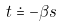<formula> <loc_0><loc_0><loc_500><loc_500>t \doteq - \beta s</formula> 